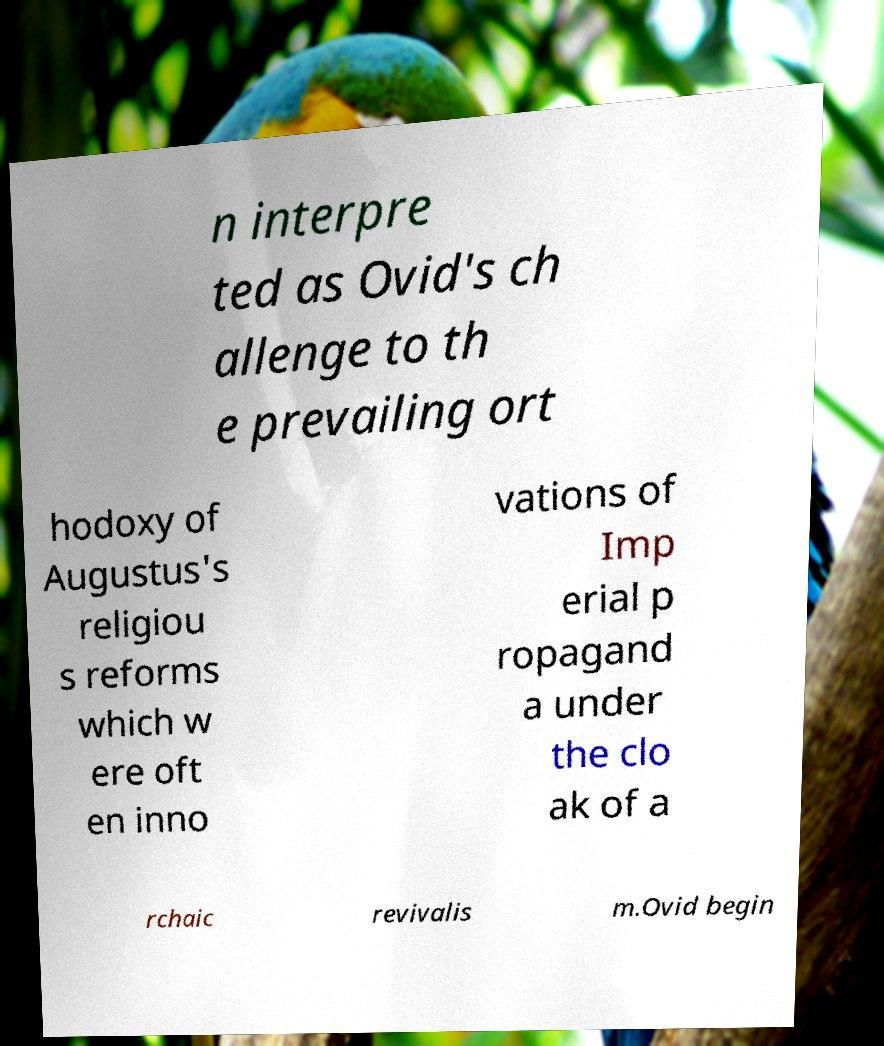There's text embedded in this image that I need extracted. Can you transcribe it verbatim? n interpre ted as Ovid's ch allenge to th e prevailing ort hodoxy of Augustus's religiou s reforms which w ere oft en inno vations of Imp erial p ropagand a under the clo ak of a rchaic revivalis m.Ovid begin 